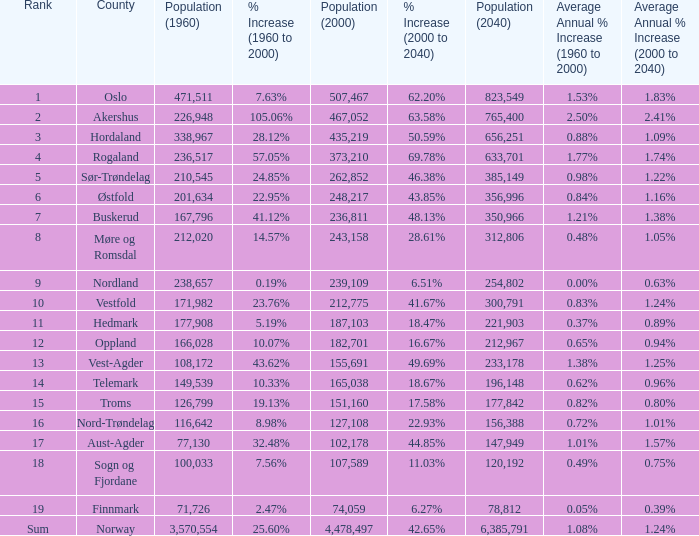What was the population of a county in 2040 that had a population less than 108,172 in 2000 and less than 107,589 in 1960? 2.0. 